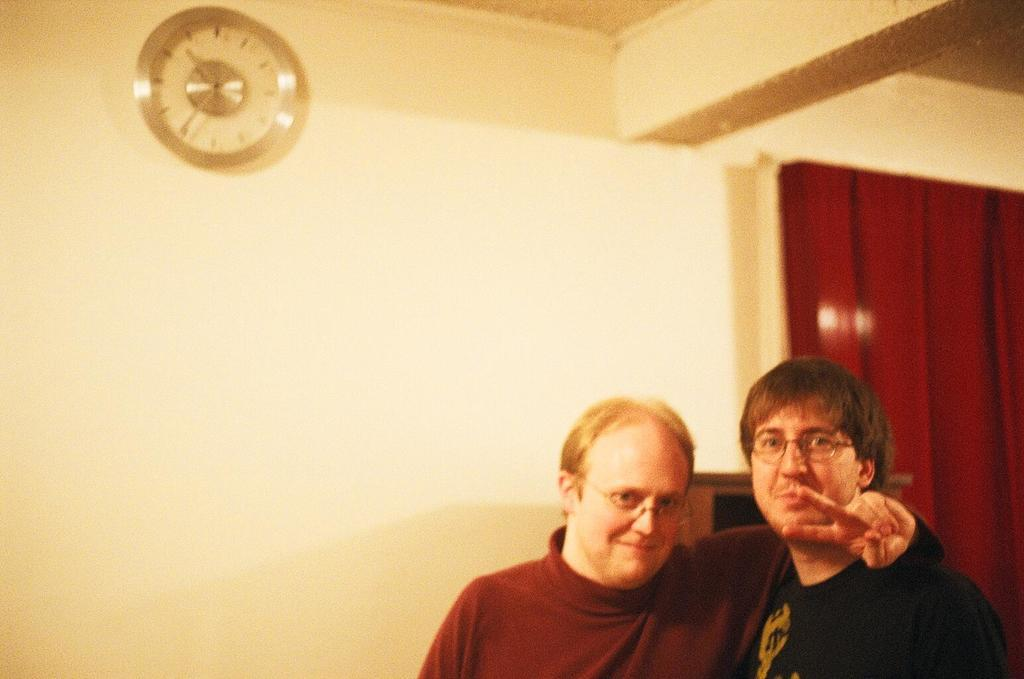Who or what can be seen on the right side of the image? There are two people on the right side of the image. What is visible in the background of the image? There is a wall in the background of the image. Can you identify any specific object in the image? Yes, there is a watch in the image. What type of window treatment is present in the image? There is a curtain on the right side of the image. How many flowers are on the bed in the image? There is no bed or flowers present in the image. What type of box is visible on the left side of the image? There is no box visible in the image. 